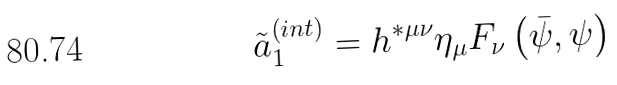Convert formula to latex. <formula><loc_0><loc_0><loc_500><loc_500>\tilde { a } _ { 1 } ^ { \left ( i n t \right ) } = h ^ { * \mu \nu } \eta _ { \mu } F _ { \nu } \left ( \bar { \psi } , \psi \right )</formula> 